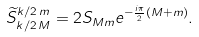<formula> <loc_0><loc_0><loc_500><loc_500>\widetilde { S } _ { k / 2 \, M } ^ { k / 2 \, m } = 2 S _ { M m } e ^ { - \frac { i \pi } { 2 } ( M + m ) } .</formula> 